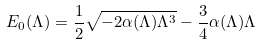<formula> <loc_0><loc_0><loc_500><loc_500>E _ { 0 } ( \Lambda ) = \frac { 1 } { 2 } \sqrt { - 2 \alpha ( \Lambda ) \Lambda ^ { 3 } } - \frac { 3 } { 4 } \alpha ( \Lambda ) \Lambda</formula> 